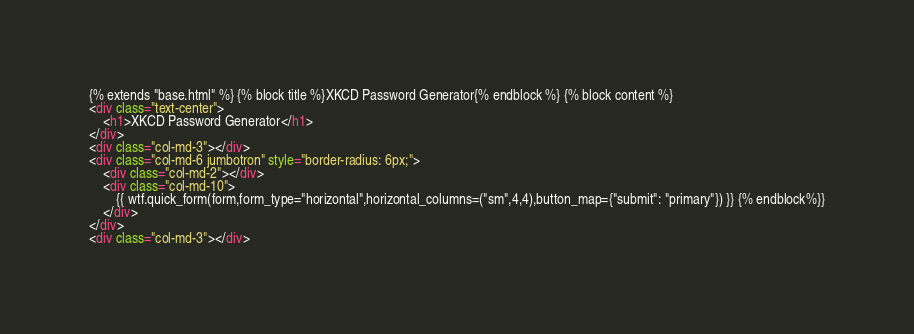<code> <loc_0><loc_0><loc_500><loc_500><_HTML_>{% extends "base.html" %} {% block title %}XKCD Password Generator{% endblock %} {% block content %}
<div class="text-center">
    <h1>XKCD Password Generator</h1>
</div>
<div class="col-md-3"></div>
<div class="col-md-6 jumbotron" style="border-radius: 6px;">
    <div class="col-md-2"></div>
    <div class="col-md-10">
        {{ wtf.quick_form(form,form_type="horizontal",horizontal_columns=("sm",4,4),button_map={"submit": "primary"}) }} {% endblock%}}
    </div>
</div>
<div class="col-md-3"></div></code> 